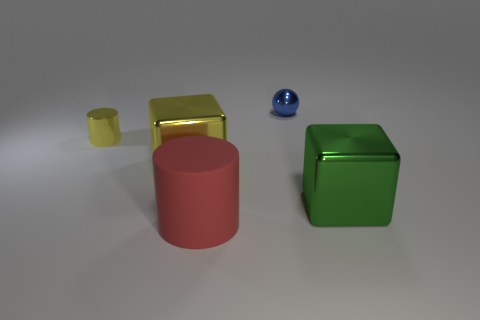Are there an equal number of big green cubes that are behind the large yellow cube and big blocks to the left of the small yellow shiny thing?
Provide a short and direct response. Yes. Is there a metal ball that is in front of the large object that is on the right side of the tiny blue ball?
Provide a short and direct response. No. What is the shape of the large green metal thing?
Offer a terse response. Cube. What is the size of the metal cube that is the same color as the shiny cylinder?
Ensure brevity in your answer.  Large. There is a cylinder in front of the cylinder behind the large yellow block; what size is it?
Your answer should be very brief. Large. What is the size of the shiny block behind the big green metallic object?
Offer a very short reply. Large. Is the number of large metallic things on the right side of the large red object less than the number of tiny objects that are to the right of the small yellow metallic cylinder?
Provide a short and direct response. No. What is the color of the matte cylinder?
Provide a succinct answer. Red. Is there a large matte sphere that has the same color as the metallic cylinder?
Your answer should be compact. No. There is a small thing in front of the tiny metal object to the right of the yellow metallic object that is in front of the shiny cylinder; what is its shape?
Your response must be concise. Cylinder. 